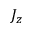<formula> <loc_0><loc_0><loc_500><loc_500>J _ { z }</formula> 